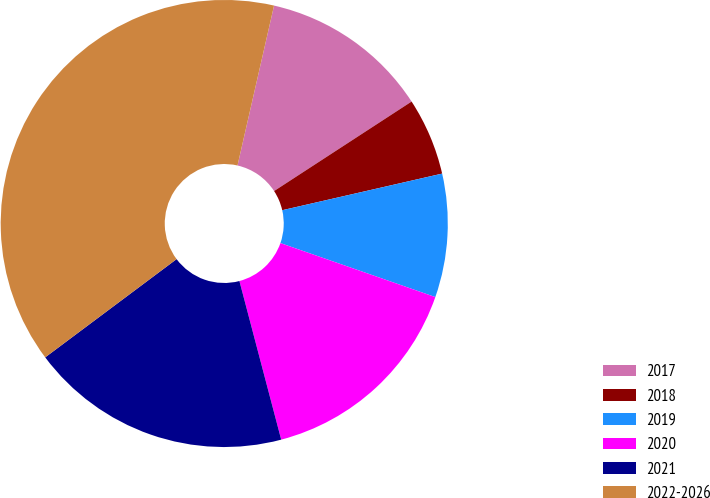Convert chart. <chart><loc_0><loc_0><loc_500><loc_500><pie_chart><fcel>2017<fcel>2018<fcel>2019<fcel>2020<fcel>2021<fcel>2022-2026<nl><fcel>12.24%<fcel>5.6%<fcel>8.92%<fcel>15.56%<fcel>18.88%<fcel>38.79%<nl></chart> 